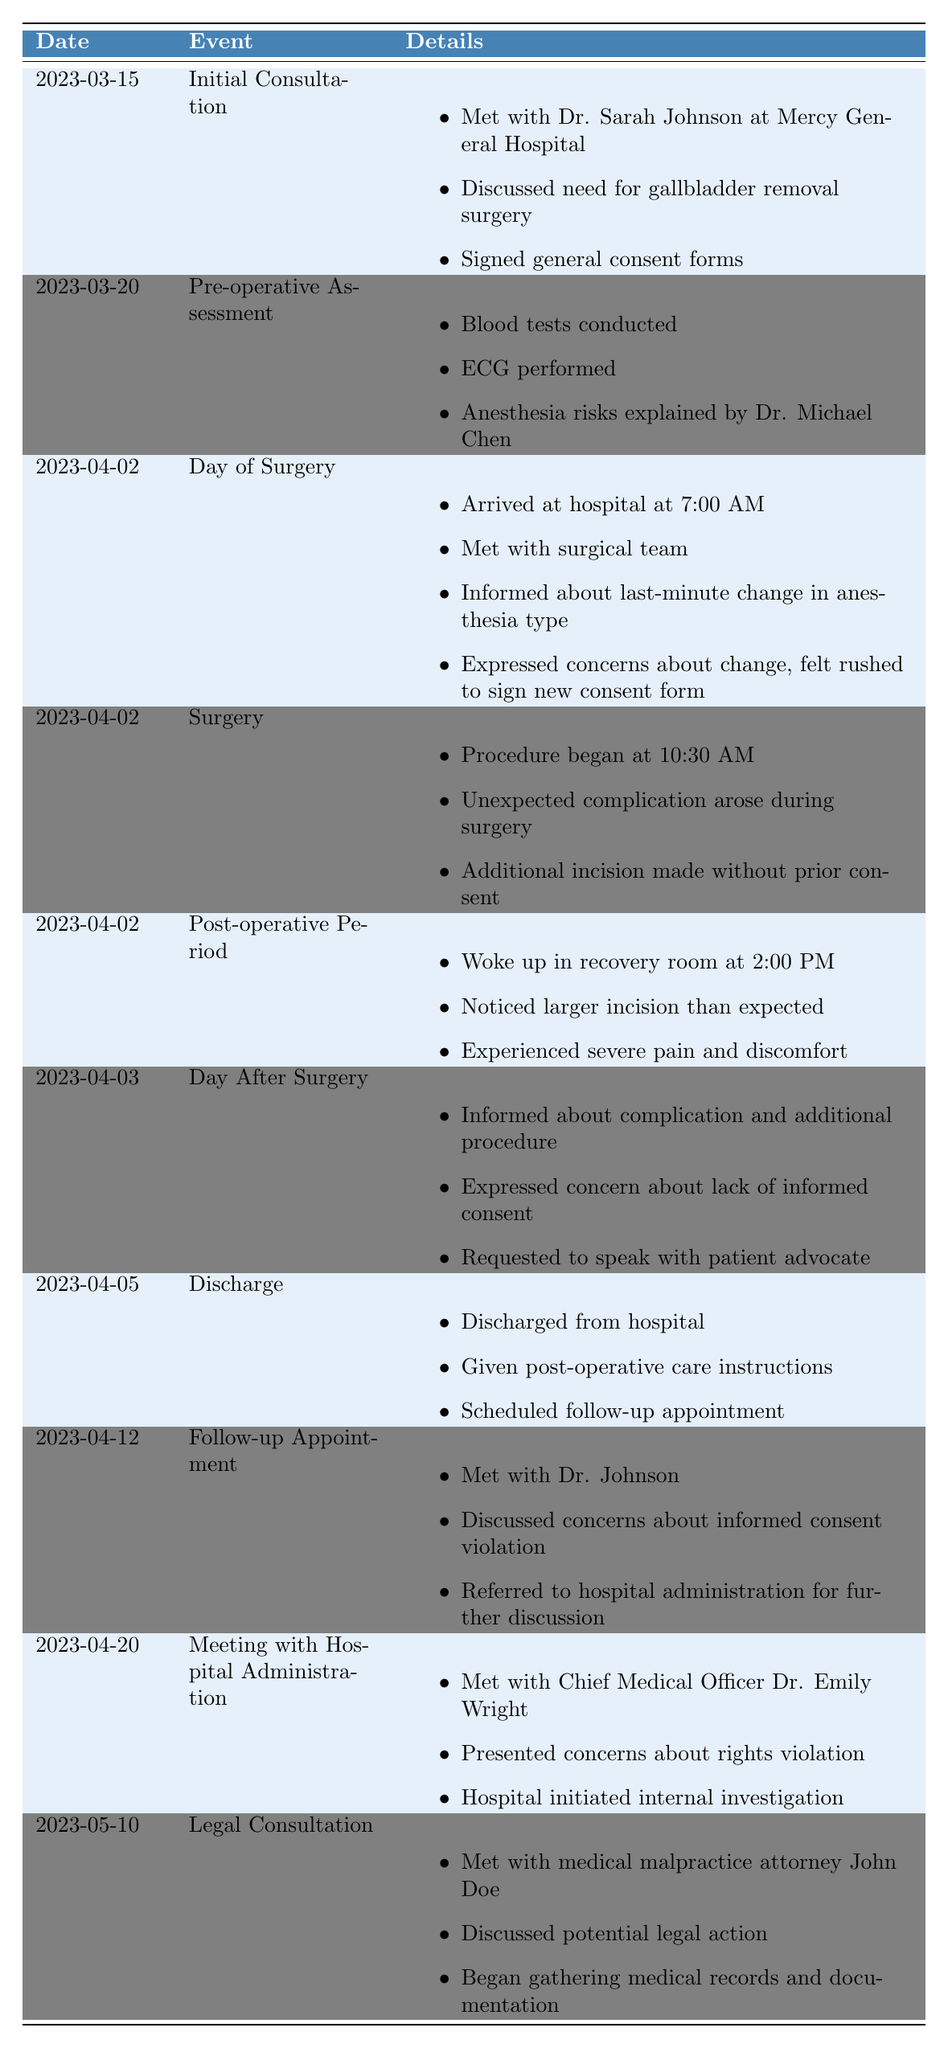What date did the initial consultation take place? The table lists the event "Initial Consultation" on the date "2023-03-15."
Answer: 2023-03-15 Who was the surgeon met during the initial consultation? The details for the "Initial Consultation" mention meeting with "Dr. Sarah Johnson."
Answer: Dr. Sarah Johnson What event followed the discharge from the hospital? The event following "Discharge" on "2023-04-05" is the "Follow-up Appointment" on "2023-04-12."
Answer: Follow-up Appointment Was there a change in anesthesia type on the day of surgery? The details under "Day of Surgery" indicate that there was a "last-minute change in anesthesia type."
Answer: Yes How many days after the surgery did the patient have a follow-up appointment? The surgery occurred on "2023-04-02," and the follow-up appointment was on "2023-04-12," which is 10 days later.
Answer: 10 days What additional procedure occurred without prior consent? The event "Surgery" mentions that an "additional incision was made without prior consent."
Answer: Additional incision On what date did the patient meet with hospital administration? The table shows that the meeting with hospital administration occurred on "2023-04-20."
Answer: 2023-04-20 Was there a consultation with a medical malpractice attorney, and if so, when? The table lists a "Legal Consultation" on "2023-05-10," confirming that there was such a meeting.
Answer: Yes, on 2023-05-10 What concerns did the patient express during the day after surgery? On "2023-04-03," the patient expressed concerns about the "lack of informed consent."
Answer: Lack of informed consent How many events are listed on the same date as the surgery? The day of surgery on "2023-04-02" has three events: "Day of Surgery," "Surgery," and "Post-operative Period," totaling three events.
Answer: 3 events What was the first event listed in the timeline? The first event is "Initial Consultation," which occurred on the date "2023-03-15."
Answer: Initial Consultation What did the patient request after being informed of the complication? The patient requested to "speak with patient advocate" on "2023-04-03."
Answer: Speak with patient advocate What action did the hospital take after the meeting with the Chief Medical Officer? Following the meeting on "2023-04-20," the hospital "initiated an internal investigation."
Answer: Initiated internal investigation Was anesthesia risk discussed during the pre-operative assessment? The details for "Pre-operative Assessment" include that "anesthesia risks were explained by Dr. Michael Chen."
Answer: Yes What was the patient's experience upon waking up in recovery? The patient experienced "severe pain and discomfort" after waking up in recovery on "2023-04-02."
Answer: Severe pain and discomfort Did the patient have a meeting with an attorney before meeting with hospital administration? The "Legal Consultation" was held on "2023-05-10," which is after the meeting with hospital administration on "2023-04-20," thus confirming the sequence.
Answer: Yes 